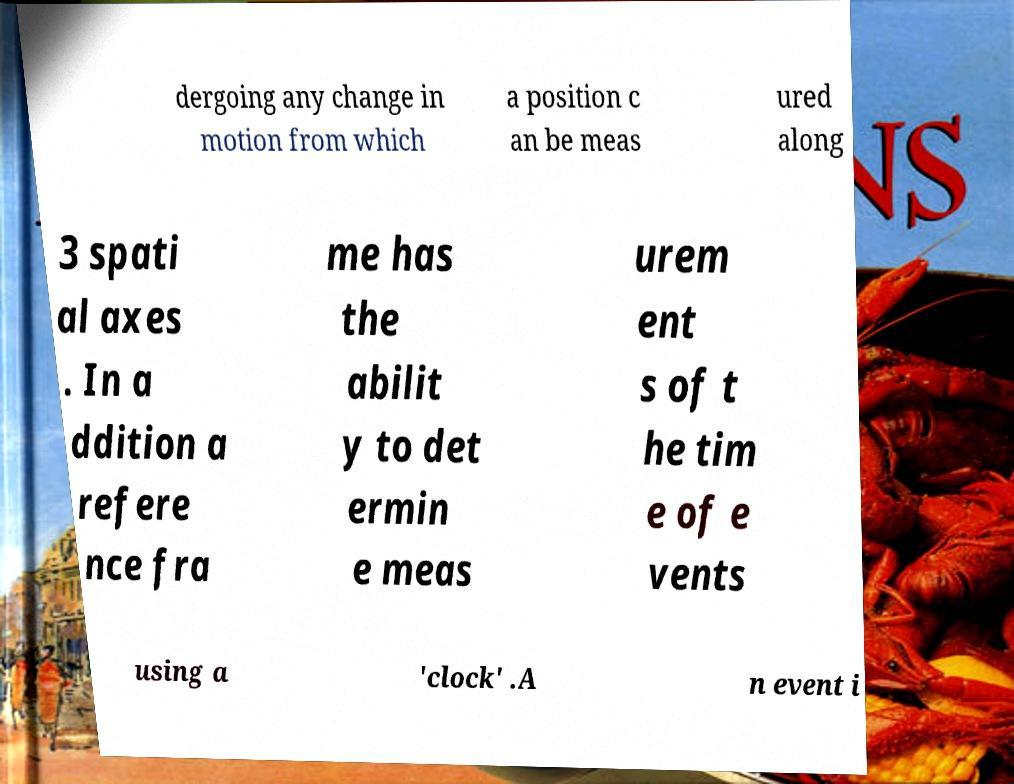Can you accurately transcribe the text from the provided image for me? dergoing any change in motion from which a position c an be meas ured along 3 spati al axes . In a ddition a refere nce fra me has the abilit y to det ermin e meas urem ent s of t he tim e of e vents using a 'clock' .A n event i 